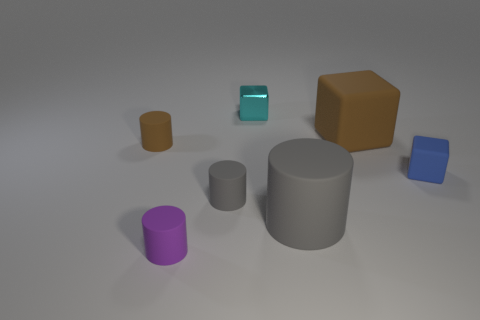What number of objects are either matte objects or tiny blue matte cubes?
Provide a succinct answer. 6. What number of other things are the same size as the purple cylinder?
Your response must be concise. 4. How many objects are in front of the large matte cube and to the right of the cyan block?
Your answer should be compact. 2. Do the matte cylinder that is on the left side of the purple cylinder and the cube that is to the right of the brown rubber block have the same size?
Offer a terse response. Yes. There is a brown matte thing that is on the left side of the cyan metal thing; what size is it?
Ensure brevity in your answer.  Small. What number of objects are objects that are on the left side of the cyan shiny cube or objects in front of the large rubber cube?
Your response must be concise. 5. Is there any other thing that has the same color as the tiny metal cube?
Provide a succinct answer. No. Are there an equal number of brown matte cubes in front of the small gray matte cylinder and small blue blocks that are behind the big gray matte cylinder?
Make the answer very short. No. Is the number of large brown blocks that are in front of the purple matte object greater than the number of brown cubes?
Give a very brief answer. No. How many objects are either small matte cylinders that are in front of the small brown matte thing or small green rubber things?
Give a very brief answer. 2. 